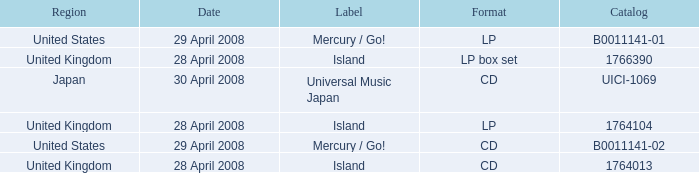What is the Label of the UICI-1069 Catalog? Universal Music Japan. 